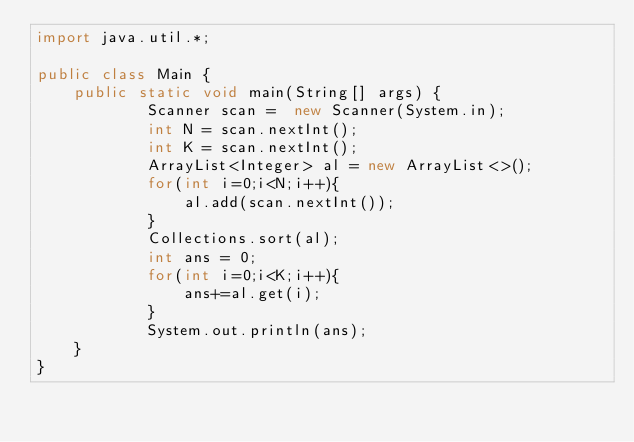<code> <loc_0><loc_0><loc_500><loc_500><_Java_>import java.util.*;

public class Main {
	public static void main(String[] args) {
			Scanner scan =  new Scanner(System.in);
			int N = scan.nextInt();
			int K = scan.nextInt();
			ArrayList<Integer> al = new ArrayList<>();
			for(int i=0;i<N;i++){
				al.add(scan.nextInt());
			}
			Collections.sort(al);
			int ans = 0;
			for(int i=0;i<K;i++){
				ans+=al.get(i);
			}
			System.out.println(ans);
	}
}
</code> 